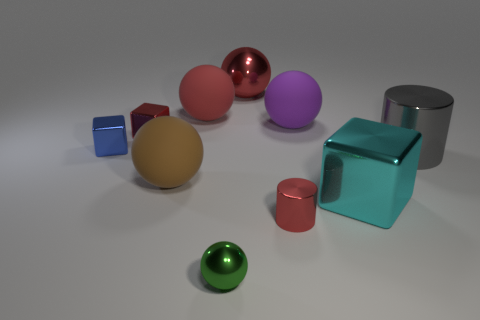What are the different colors and shapes included in this collection of objects? The image features a variety of colors including red, purple, turquoise, gold, silver, and shades of blue. As for shapes, there's a variety of geometrical forms present: spheres, cubes, and cylinders. 